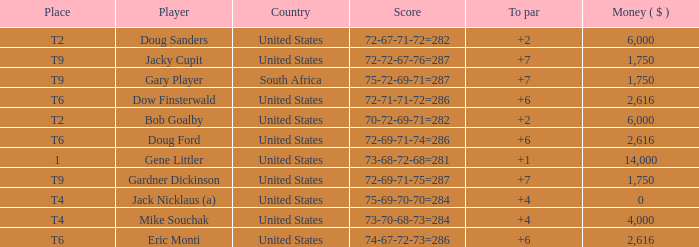What is the highest To Par, when Place is "1"? 1.0. Could you parse the entire table? {'header': ['Place', 'Player', 'Country', 'Score', 'To par', 'Money ( $ )'], 'rows': [['T2', 'Doug Sanders', 'United States', '72-67-71-72=282', '+2', '6,000'], ['T9', 'Jacky Cupit', 'United States', '72-72-67-76=287', '+7', '1,750'], ['T9', 'Gary Player', 'South Africa', '75-72-69-71=287', '+7', '1,750'], ['T6', 'Dow Finsterwald', 'United States', '72-71-71-72=286', '+6', '2,616'], ['T2', 'Bob Goalby', 'United States', '70-72-69-71=282', '+2', '6,000'], ['T6', 'Doug Ford', 'United States', '72-69-71-74=286', '+6', '2,616'], ['1', 'Gene Littler', 'United States', '73-68-72-68=281', '+1', '14,000'], ['T9', 'Gardner Dickinson', 'United States', '72-69-71-75=287', '+7', '1,750'], ['T4', 'Jack Nicklaus (a)', 'United States', '75-69-70-70=284', '+4', '0'], ['T4', 'Mike Souchak', 'United States', '73-70-68-73=284', '+4', '4,000'], ['T6', 'Eric Monti', 'United States', '74-67-72-73=286', '+6', '2,616']]} 